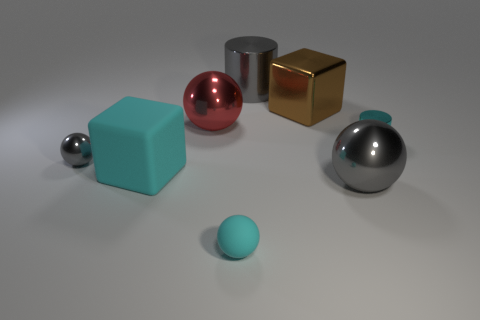How does the lighting in this image affect the appearance of the objects? The lighting in the image appears to be soft and diffused, coming from above, as indicated by the soft shadows beneath the objects. This type of lighting enhances the objects' dimensions and produces gentle shadows, contributing to the understanding of their shapes and volumes. The reflective surfaces of the metal objects display highlights and subdued reflections, creating a sense of depth and realism. Meanwhile, the more matte surfaces absorb the light, allowing the objects' colors to remain consistent and vivid, without harsh glare. 